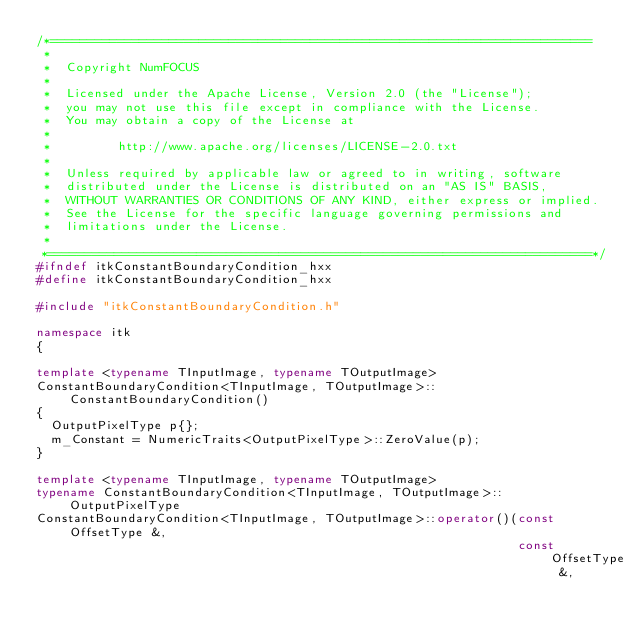<code> <loc_0><loc_0><loc_500><loc_500><_C++_>/*=========================================================================
 *
 *  Copyright NumFOCUS
 *
 *  Licensed under the Apache License, Version 2.0 (the "License");
 *  you may not use this file except in compliance with the License.
 *  You may obtain a copy of the License at
 *
 *         http://www.apache.org/licenses/LICENSE-2.0.txt
 *
 *  Unless required by applicable law or agreed to in writing, software
 *  distributed under the License is distributed on an "AS IS" BASIS,
 *  WITHOUT WARRANTIES OR CONDITIONS OF ANY KIND, either express or implied.
 *  See the License for the specific language governing permissions and
 *  limitations under the License.
 *
 *=========================================================================*/
#ifndef itkConstantBoundaryCondition_hxx
#define itkConstantBoundaryCondition_hxx

#include "itkConstantBoundaryCondition.h"

namespace itk
{

template <typename TInputImage, typename TOutputImage>
ConstantBoundaryCondition<TInputImage, TOutputImage>::ConstantBoundaryCondition()
{
  OutputPixelType p{};
  m_Constant = NumericTraits<OutputPixelType>::ZeroValue(p);
}

template <typename TInputImage, typename TOutputImage>
typename ConstantBoundaryCondition<TInputImage, TOutputImage>::OutputPixelType
ConstantBoundaryCondition<TInputImage, TOutputImage>::operator()(const OffsetType &,
                                                                 const OffsetType &,</code> 